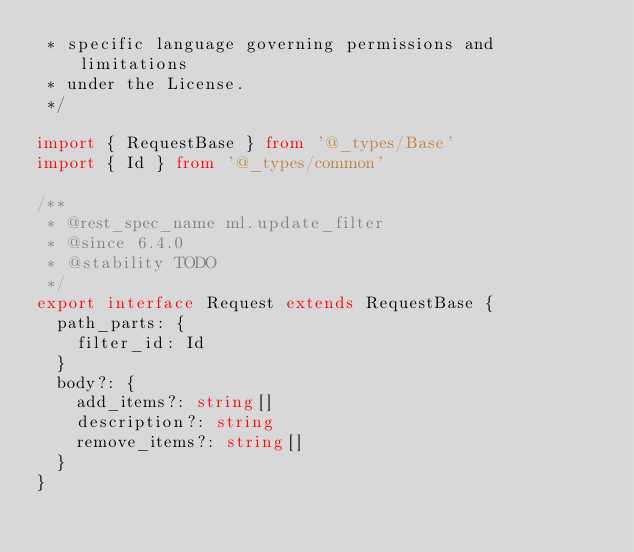<code> <loc_0><loc_0><loc_500><loc_500><_TypeScript_> * specific language governing permissions and limitations
 * under the License.
 */

import { RequestBase } from '@_types/Base'
import { Id } from '@_types/common'

/**
 * @rest_spec_name ml.update_filter
 * @since 6.4.0
 * @stability TODO
 */
export interface Request extends RequestBase {
  path_parts: {
    filter_id: Id
  }
  body?: {
    add_items?: string[]
    description?: string
    remove_items?: string[]
  }
}
</code> 